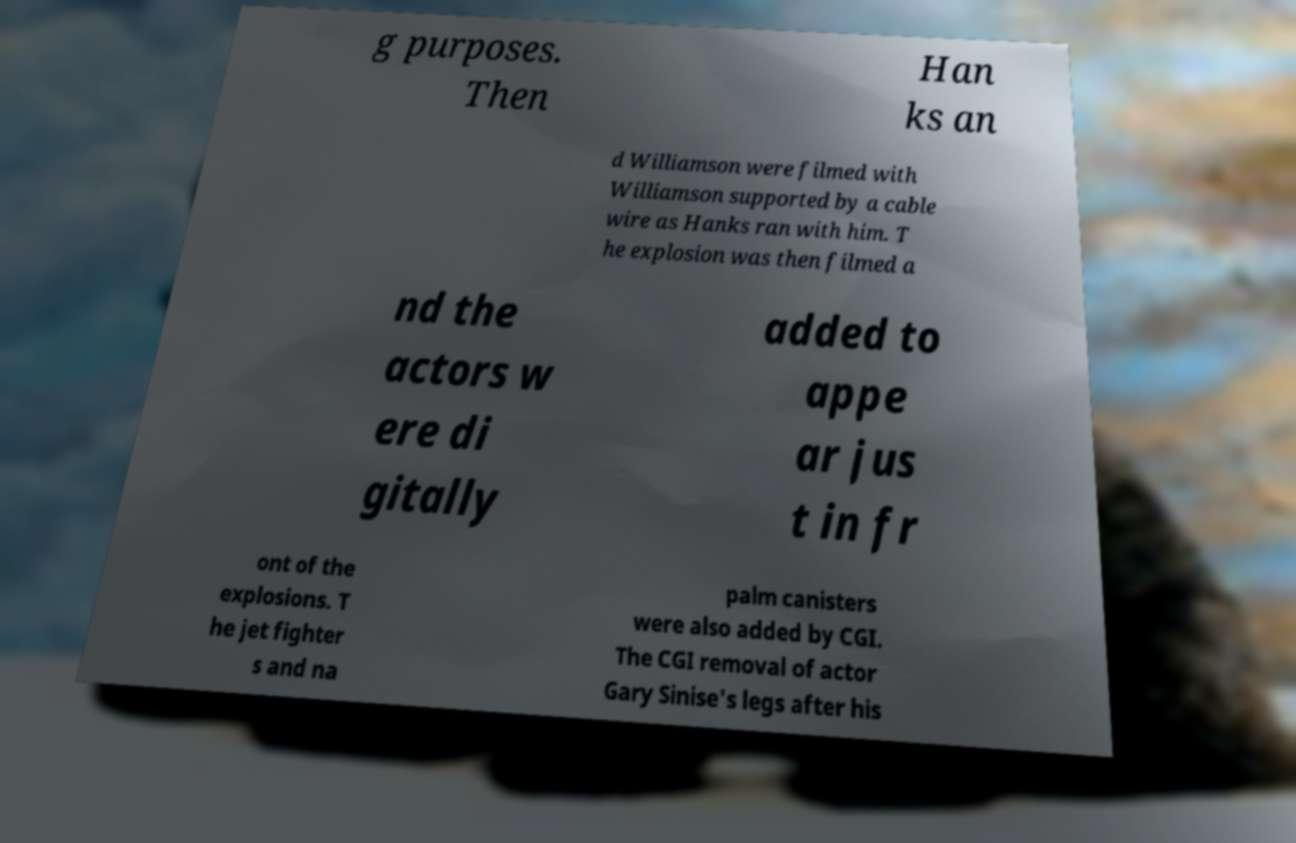There's text embedded in this image that I need extracted. Can you transcribe it verbatim? g purposes. Then Han ks an d Williamson were filmed with Williamson supported by a cable wire as Hanks ran with him. T he explosion was then filmed a nd the actors w ere di gitally added to appe ar jus t in fr ont of the explosions. T he jet fighter s and na palm canisters were also added by CGI. The CGI removal of actor Gary Sinise's legs after his 